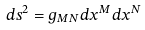<formula> <loc_0><loc_0><loc_500><loc_500>d s ^ { 2 } = g _ { M N } d x ^ { M } d x ^ { N }</formula> 